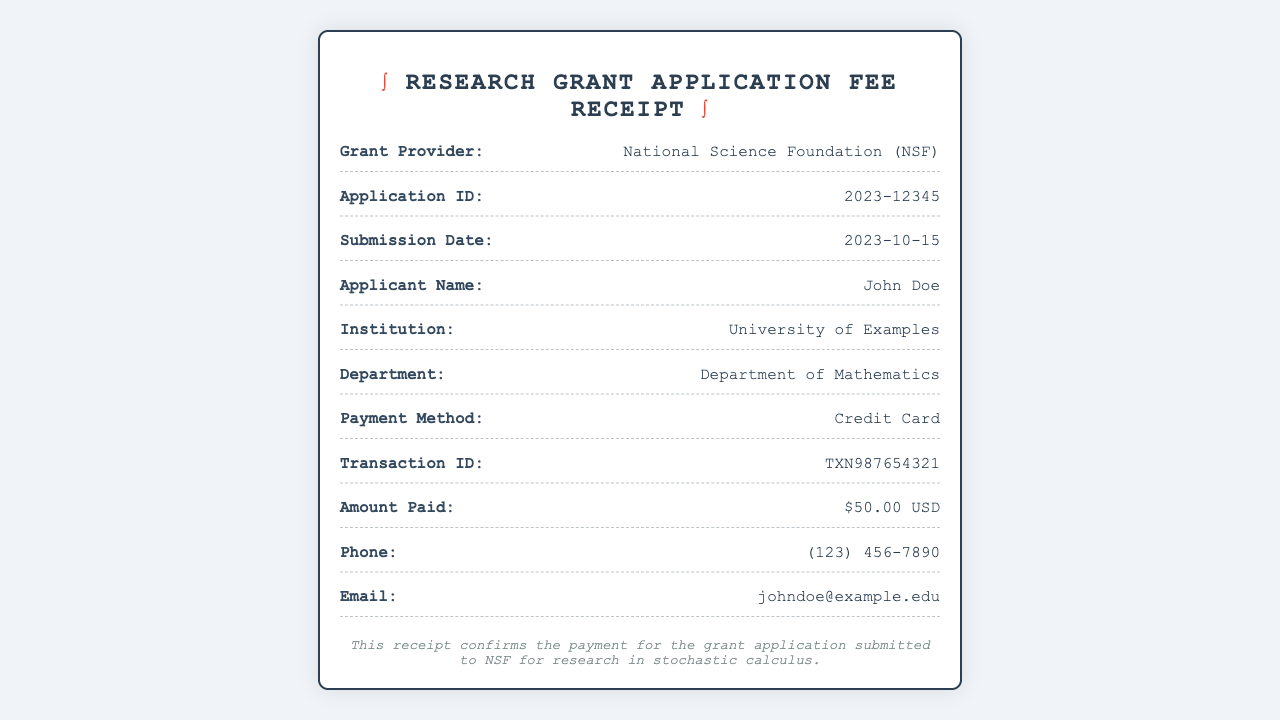What is the grant provider? The grant provider is mentioned in the document as the organization funding the research grant application.
Answer: National Science Foundation (NSF) What is the application ID? The application ID is a unique identifier specified in the document for tracking the grant application.
Answer: 2023-12345 When was the submission date? The submission date is provided in the document which indicates when the application was submitted.
Answer: 2023-10-15 What was the payment method? The payment method describes how the fee was paid, which is stated in the document.
Answer: Credit Card How much was the amount paid? The amount paid reflects the fee for the grant application as shown in the document.
Answer: $50.00 USD Who is the applicant? The applicant is the person submitting the grant application and is listed in the document.
Answer: John Doe What department is the applicant affiliated with? The department is indicated in the document as the section of the institution the applicant belongs to.
Answer: Department of Mathematics What is the transaction ID? The transaction ID is a unique number related to the payment processed for the application fee.
Answer: TXN987654321 What is the summary noted on the receipt? The summary provides a brief description of the purpose of the payment and application.
Answer: This receipt confirms the payment for the grant application submitted to NSF for research in stochastic calculus 